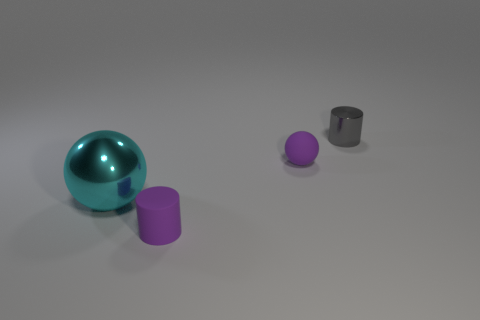Subtract 2 balls. How many balls are left? 0 Add 1 gray objects. How many objects exist? 5 Subtract all blue balls. Subtract all yellow cylinders. How many balls are left? 2 Subtract all yellow spheres. How many gray cylinders are left? 1 Subtract all small purple rubber cylinders. Subtract all red matte cylinders. How many objects are left? 3 Add 2 small gray shiny cylinders. How many small gray shiny cylinders are left? 3 Add 4 big cyan shiny balls. How many big cyan shiny balls exist? 5 Subtract 0 brown cylinders. How many objects are left? 4 